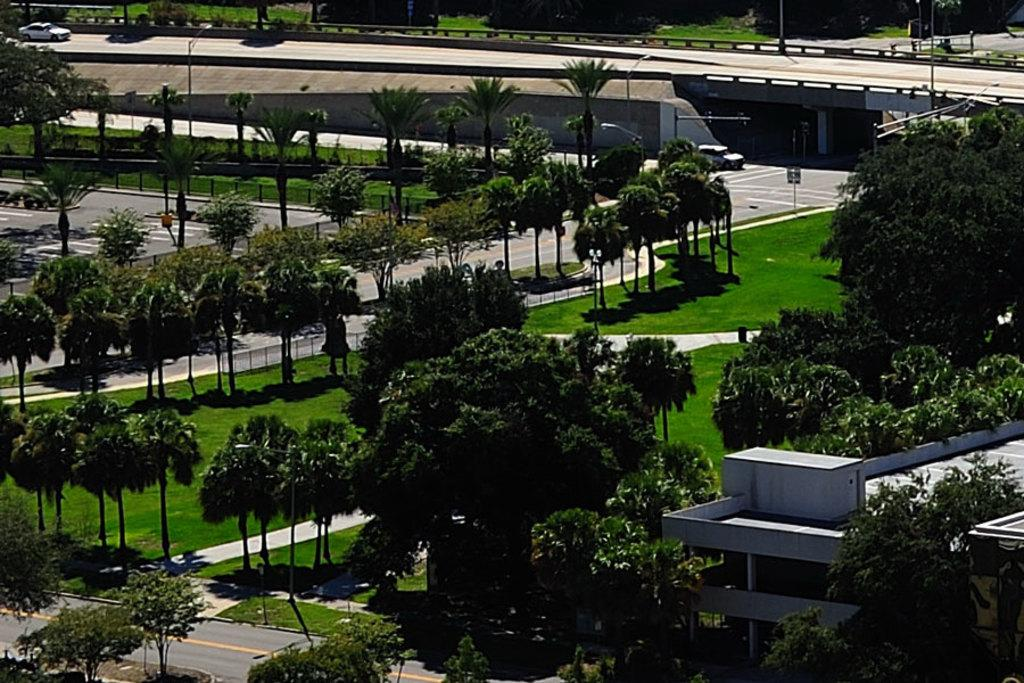What type of vegetation can be seen in the image? There are trees and grass in the image. What color are the trees and grass in the image? The trees and grass are green. What can be seen in the background of the image? There is a white building in the background of the image. What type of transportation is visible on the road in the image? There are vehicles on the road in the image. What other structures can be seen in the image? There are light poles and a bridge in the image. What type of creature is distributing army supplies in the image? There is no creature or army supplies present in the image. 